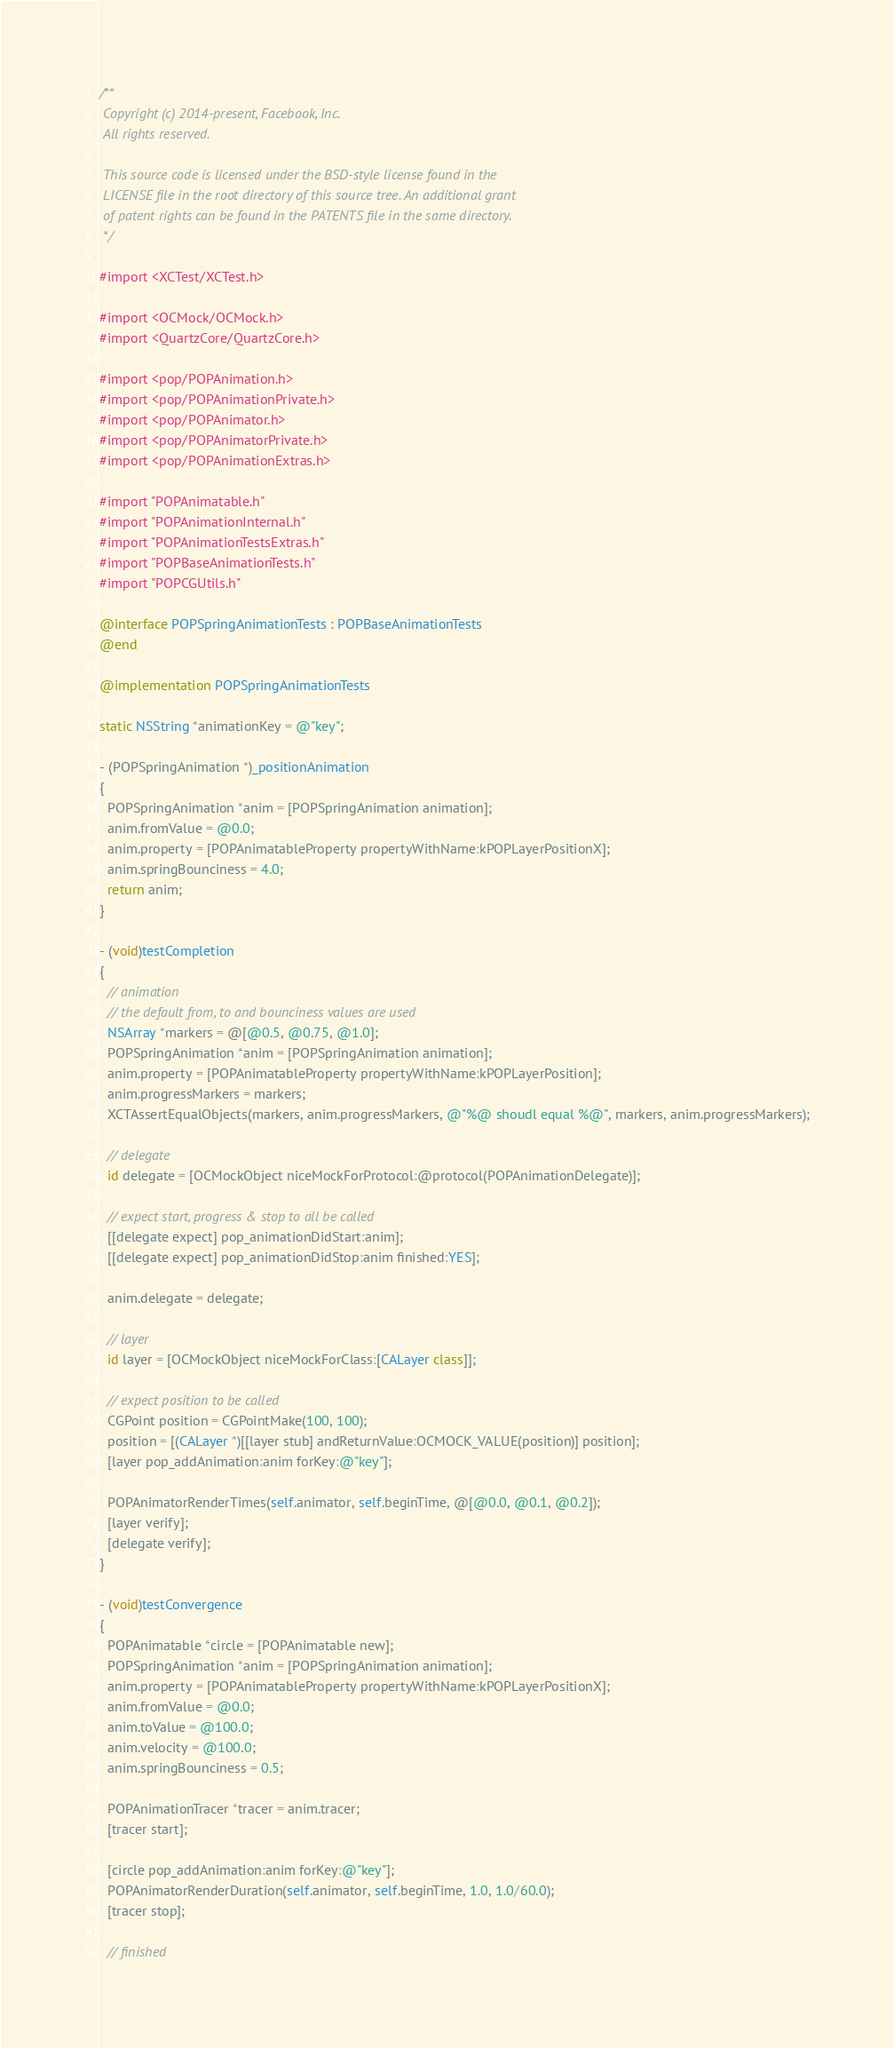Convert code to text. <code><loc_0><loc_0><loc_500><loc_500><_ObjectiveC_>/**
 Copyright (c) 2014-present, Facebook, Inc.
 All rights reserved.
 
 This source code is licensed under the BSD-style license found in the
 LICENSE file in the root directory of this source tree. An additional grant
 of patent rights can be found in the PATENTS file in the same directory.
 */

#import <XCTest/XCTest.h>

#import <OCMock/OCMock.h>
#import <QuartzCore/QuartzCore.h>

#import <pop/POPAnimation.h>
#import <pop/POPAnimationPrivate.h>
#import <pop/POPAnimator.h>
#import <pop/POPAnimatorPrivate.h>
#import <pop/POPAnimationExtras.h>

#import "POPAnimatable.h"
#import "POPAnimationInternal.h"
#import "POPAnimationTestsExtras.h"
#import "POPBaseAnimationTests.h"
#import "POPCGUtils.h"

@interface POPSpringAnimationTests : POPBaseAnimationTests
@end

@implementation POPSpringAnimationTests

static NSString *animationKey = @"key";

- (POPSpringAnimation *)_positionAnimation
{
  POPSpringAnimation *anim = [POPSpringAnimation animation];
  anim.fromValue = @0.0;
  anim.property = [POPAnimatableProperty propertyWithName:kPOPLayerPositionX];
  anim.springBounciness = 4.0;
  return anim;
}

- (void)testCompletion
{
  // animation
  // the default from, to and bounciness values are used
  NSArray *markers = @[@0.5, @0.75, @1.0];
  POPSpringAnimation *anim = [POPSpringAnimation animation];
  anim.property = [POPAnimatableProperty propertyWithName:kPOPLayerPosition];
  anim.progressMarkers = markers;
  XCTAssertEqualObjects(markers, anim.progressMarkers, @"%@ shoudl equal %@", markers, anim.progressMarkers);

  // delegate
  id delegate = [OCMockObject niceMockForProtocol:@protocol(POPAnimationDelegate)];

  // expect start, progress & stop to all be called
  [[delegate expect] pop_animationDidStart:anim];
  [[delegate expect] pop_animationDidStop:anim finished:YES];

  anim.delegate = delegate;

  // layer
  id layer = [OCMockObject niceMockForClass:[CALayer class]];

  // expect position to be called
  CGPoint position = CGPointMake(100, 100);
  position = [(CALayer *)[[layer stub] andReturnValue:OCMOCK_VALUE(position)] position];
  [layer pop_addAnimation:anim forKey:@"key"];

  POPAnimatorRenderTimes(self.animator, self.beginTime, @[@0.0, @0.1, @0.2]);
  [layer verify];
  [delegate verify];
}

- (void)testConvergence
{
  POPAnimatable *circle = [POPAnimatable new];
  POPSpringAnimation *anim = [POPSpringAnimation animation];
  anim.property = [POPAnimatableProperty propertyWithName:kPOPLayerPositionX];
  anim.fromValue = @0.0;
  anim.toValue = @100.0;
  anim.velocity = @100.0;
  anim.springBounciness = 0.5;

  POPAnimationTracer *tracer = anim.tracer;
  [tracer start];

  [circle pop_addAnimation:anim forKey:@"key"];
  POPAnimatorRenderDuration(self.animator, self.beginTime, 1.0, 1.0/60.0);
  [tracer stop];

  // finished</code> 